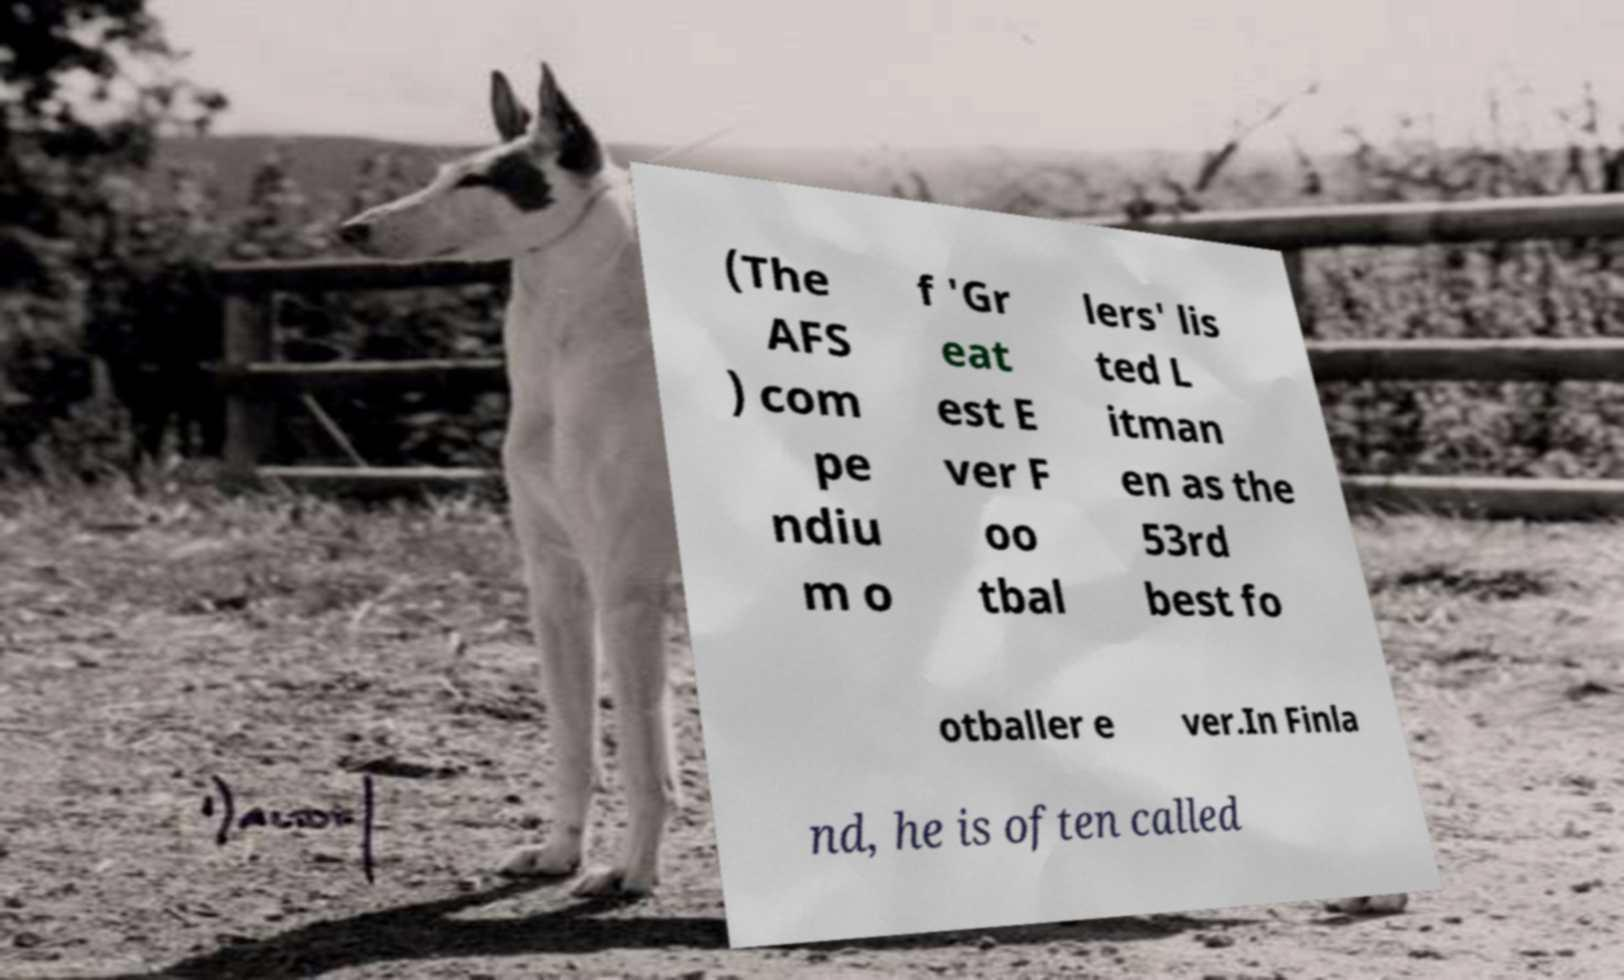I need the written content from this picture converted into text. Can you do that? (The AFS ) com pe ndiu m o f 'Gr eat est E ver F oo tbal lers' lis ted L itman en as the 53rd best fo otballer e ver.In Finla nd, he is often called 